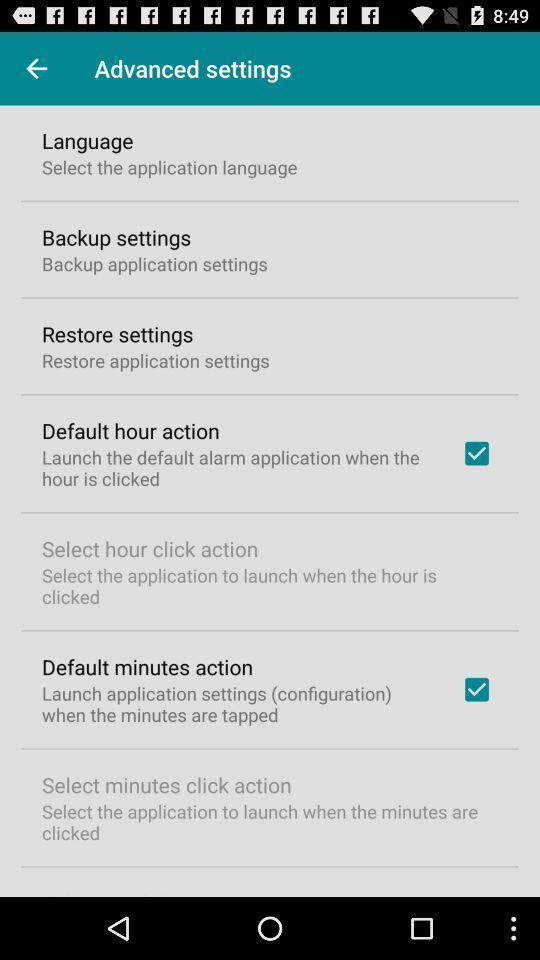What can you discern from this picture? Settings page of weather updates application. 